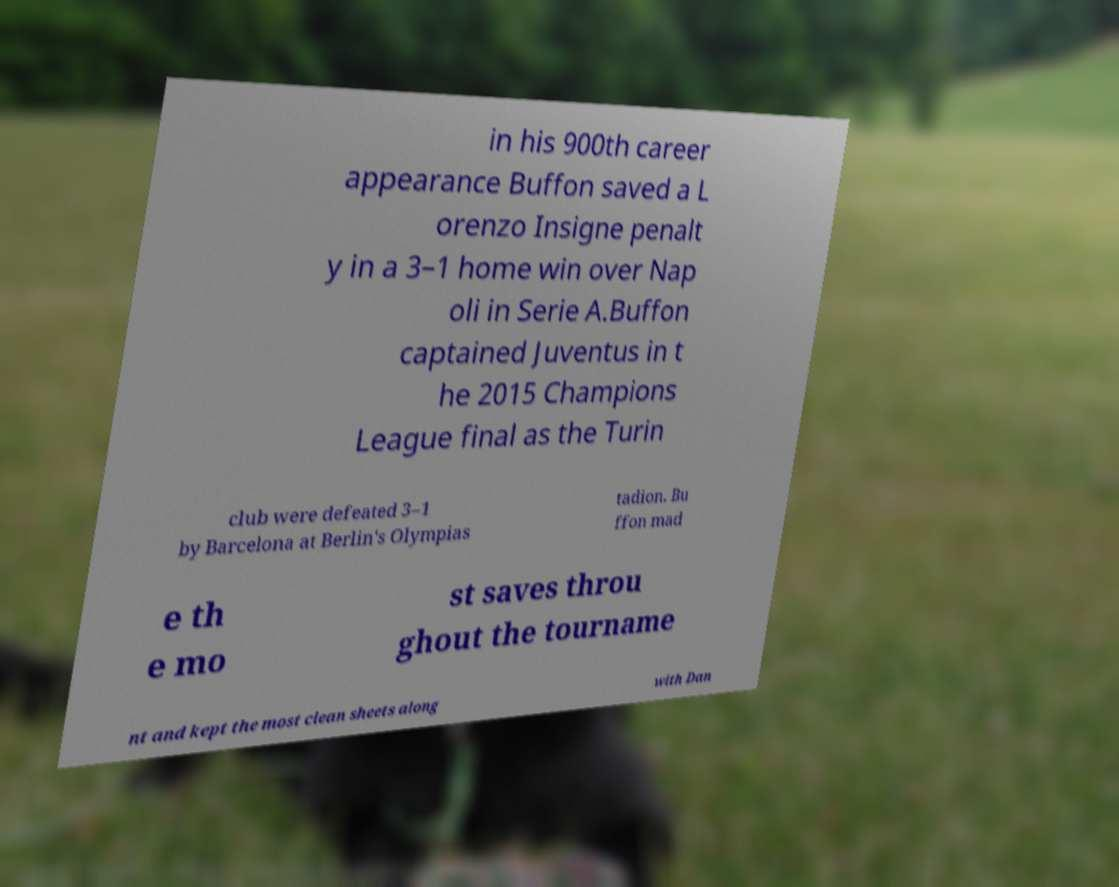What messages or text are displayed in this image? I need them in a readable, typed format. in his 900th career appearance Buffon saved a L orenzo Insigne penalt y in a 3–1 home win over Nap oli in Serie A.Buffon captained Juventus in t he 2015 Champions League final as the Turin club were defeated 3–1 by Barcelona at Berlin's Olympias tadion. Bu ffon mad e th e mo st saves throu ghout the tourname nt and kept the most clean sheets along with Dan 